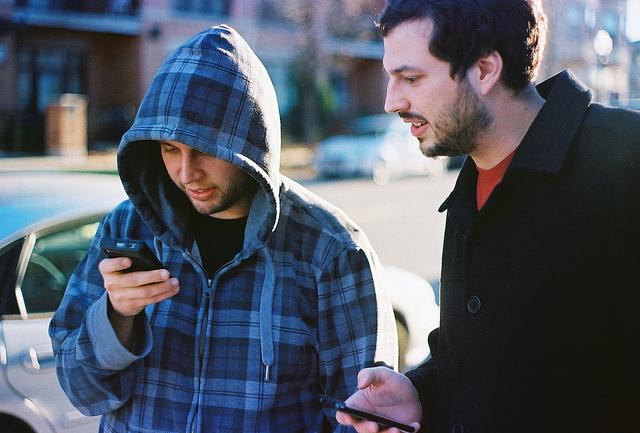Is the boy on the phone eating something?
Be succinct. No. What vehicles are shown?
Answer briefly. Cars. Are the men in the city?
Write a very short answer. Yes. What is the man in the hooded jacket doing in this picture?
Keep it brief. Texting. What is the man wearing on his face?
Write a very short answer. Beard. What is the pattern of the brighter blue shirt?
Keep it brief. Plaid. Are these people a couple?
Be succinct. No. 